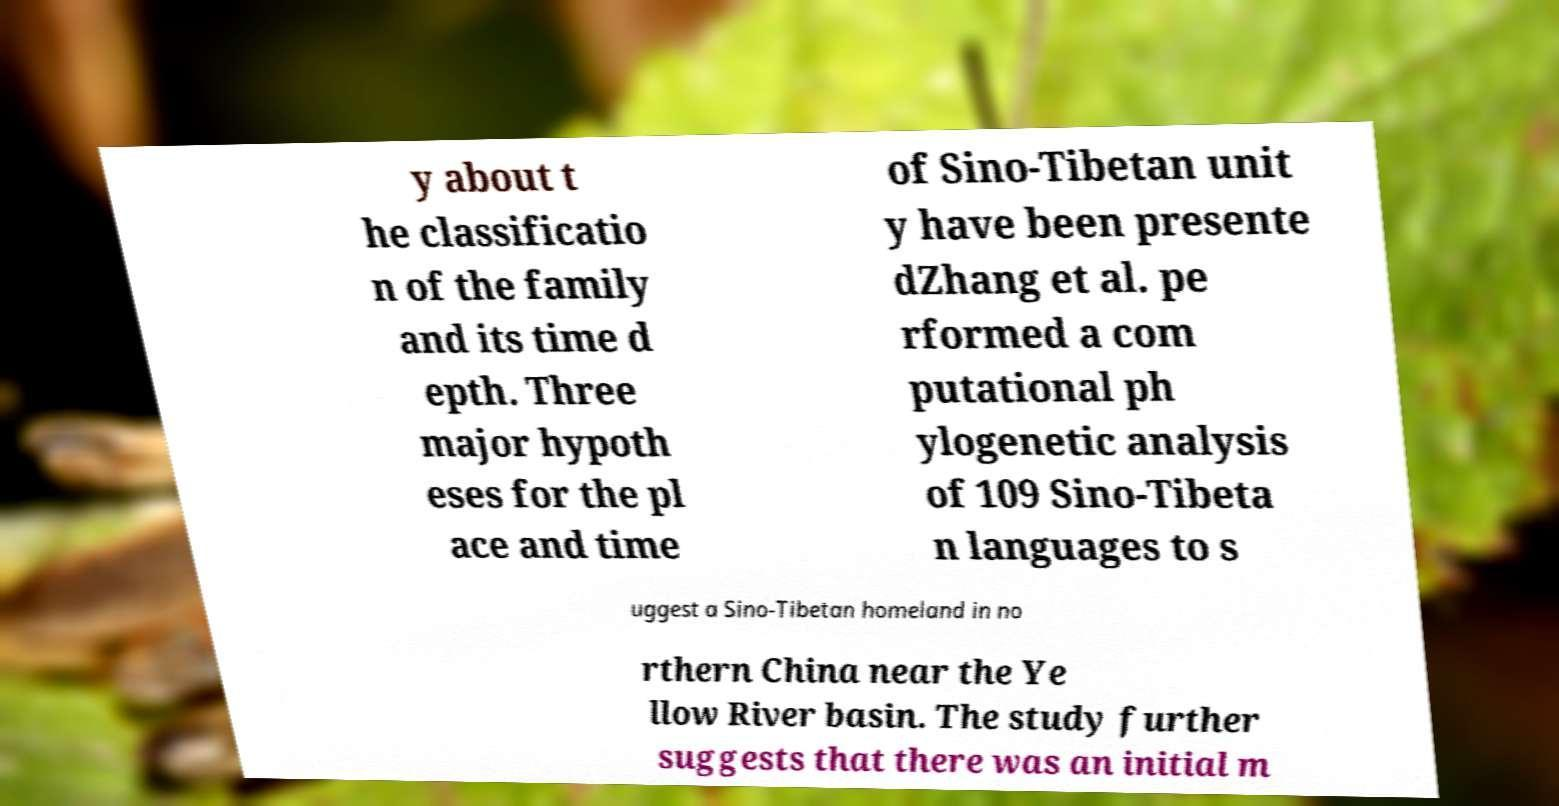For documentation purposes, I need the text within this image transcribed. Could you provide that? y about t he classificatio n of the family and its time d epth. Three major hypoth eses for the pl ace and time of Sino-Tibetan unit y have been presente dZhang et al. pe rformed a com putational ph ylogenetic analysis of 109 Sino-Tibeta n languages to s uggest a Sino-Tibetan homeland in no rthern China near the Ye llow River basin. The study further suggests that there was an initial m 